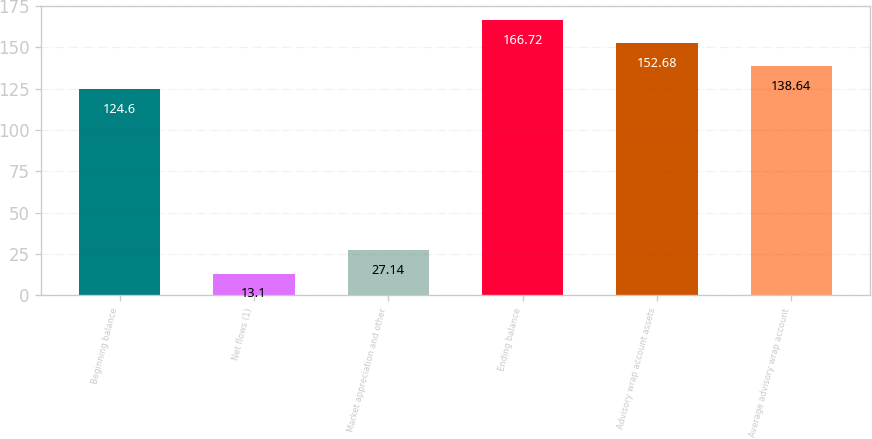Convert chart to OTSL. <chart><loc_0><loc_0><loc_500><loc_500><bar_chart><fcel>Beginning balance<fcel>Net flows (1)<fcel>Market appreciation and other<fcel>Ending balance<fcel>Advisory wrap account assets<fcel>Average advisory wrap account<nl><fcel>124.6<fcel>13.1<fcel>27.14<fcel>166.72<fcel>152.68<fcel>138.64<nl></chart> 